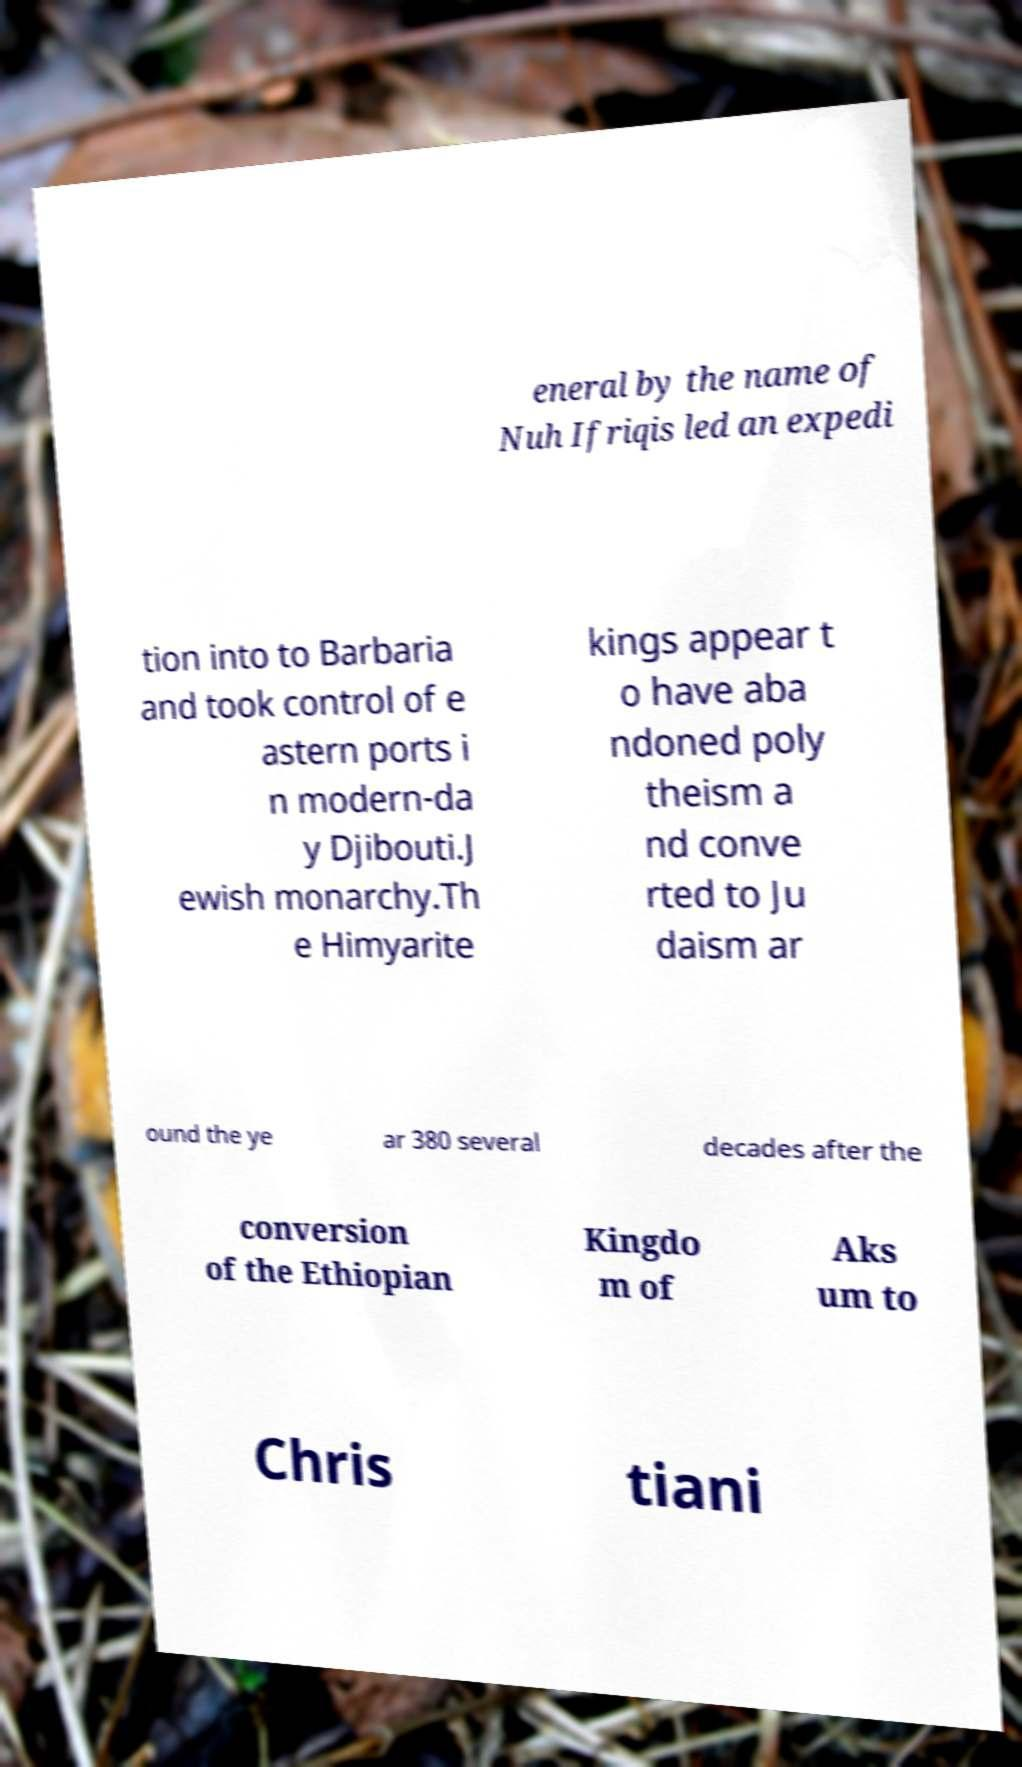What messages or text are displayed in this image? I need them in a readable, typed format. eneral by the name of Nuh Ifriqis led an expedi tion into to Barbaria and took control of e astern ports i n modern-da y Djibouti.J ewish monarchy.Th e Himyarite kings appear t o have aba ndoned poly theism a nd conve rted to Ju daism ar ound the ye ar 380 several decades after the conversion of the Ethiopian Kingdo m of Aks um to Chris tiani 